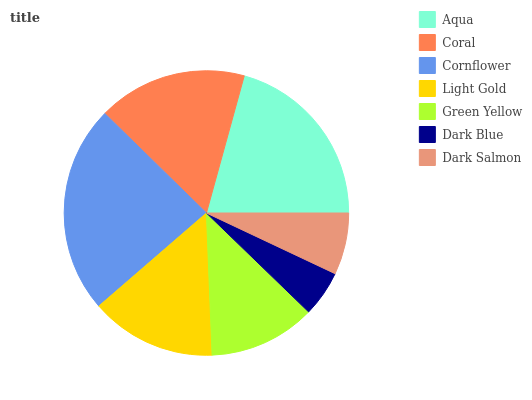Is Dark Blue the minimum?
Answer yes or no. Yes. Is Cornflower the maximum?
Answer yes or no. Yes. Is Coral the minimum?
Answer yes or no. No. Is Coral the maximum?
Answer yes or no. No. Is Aqua greater than Coral?
Answer yes or no. Yes. Is Coral less than Aqua?
Answer yes or no. Yes. Is Coral greater than Aqua?
Answer yes or no. No. Is Aqua less than Coral?
Answer yes or no. No. Is Light Gold the high median?
Answer yes or no. Yes. Is Light Gold the low median?
Answer yes or no. Yes. Is Dark Salmon the high median?
Answer yes or no. No. Is Green Yellow the low median?
Answer yes or no. No. 